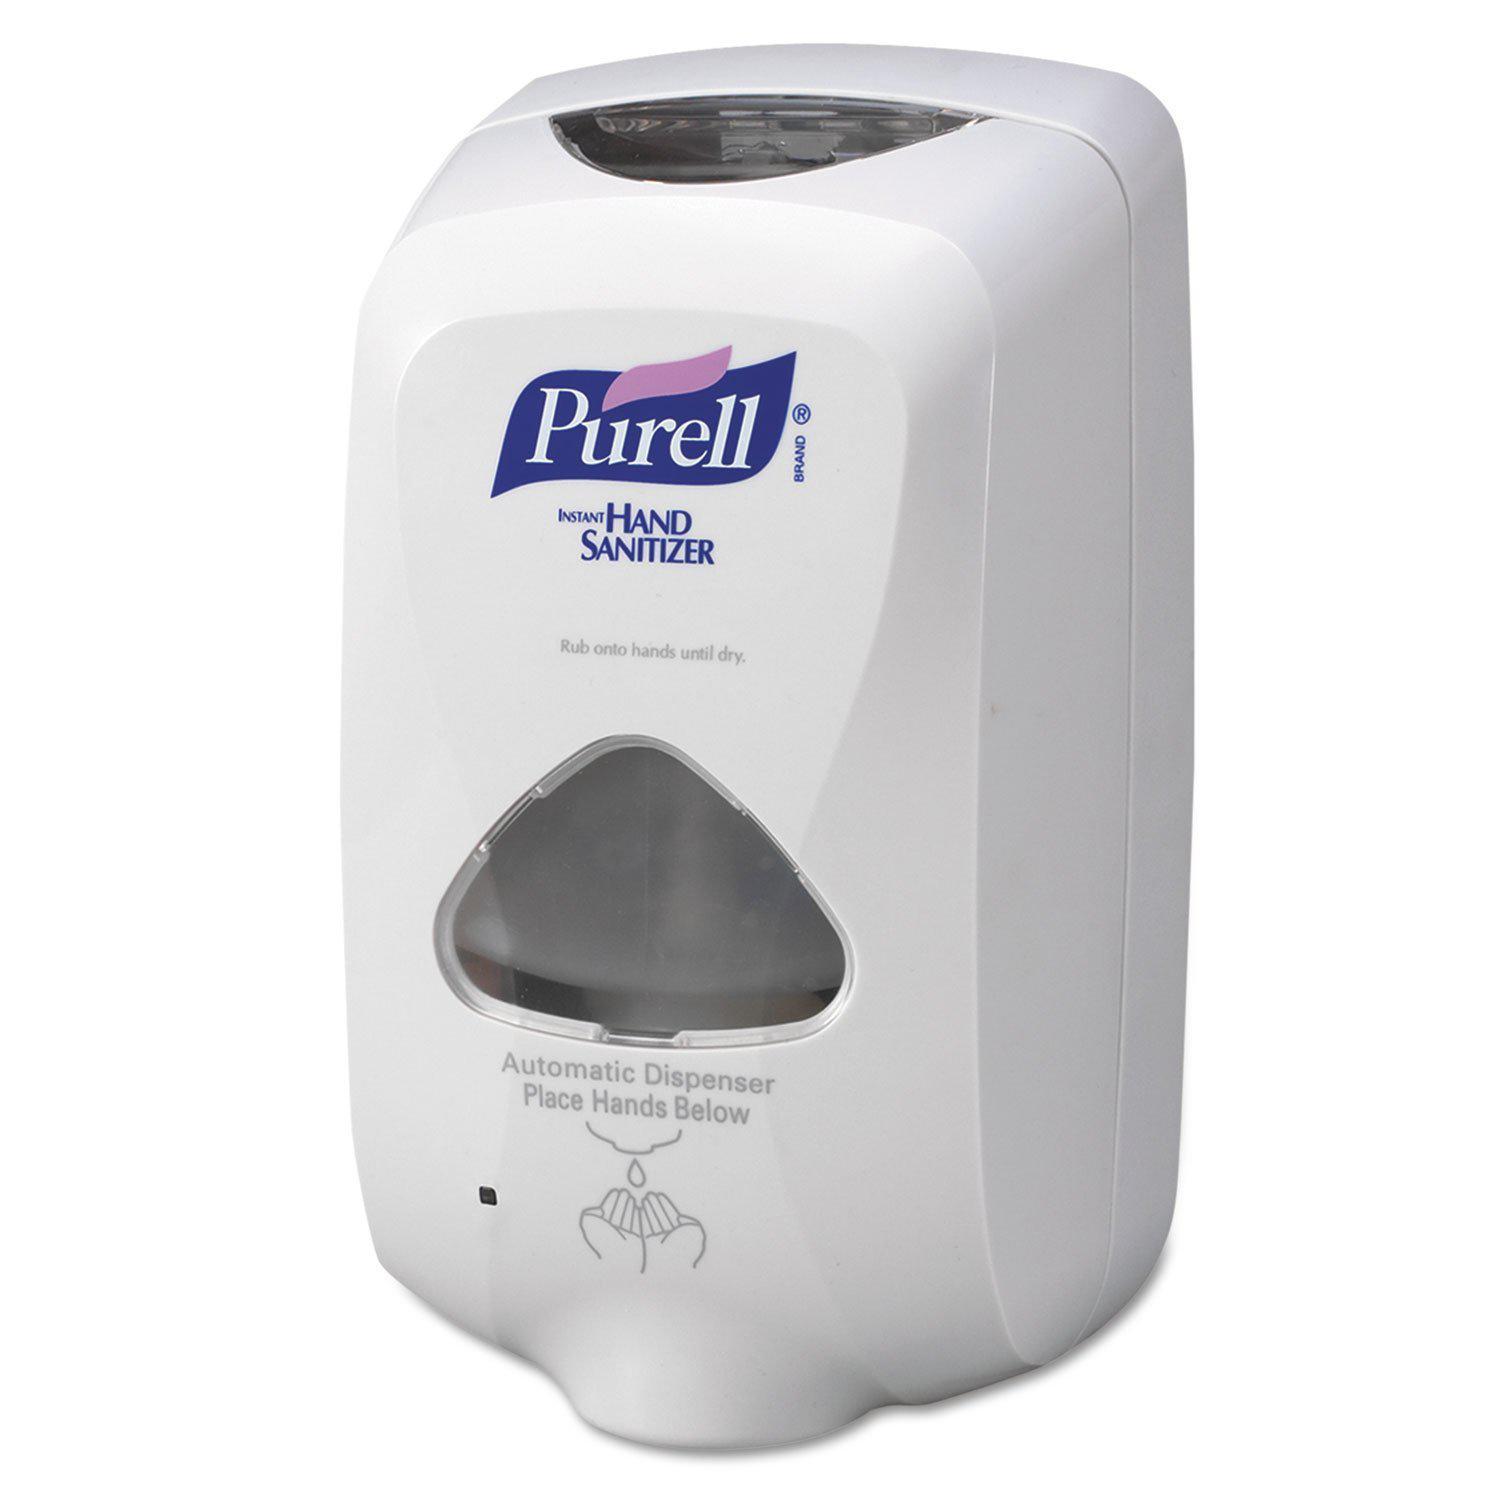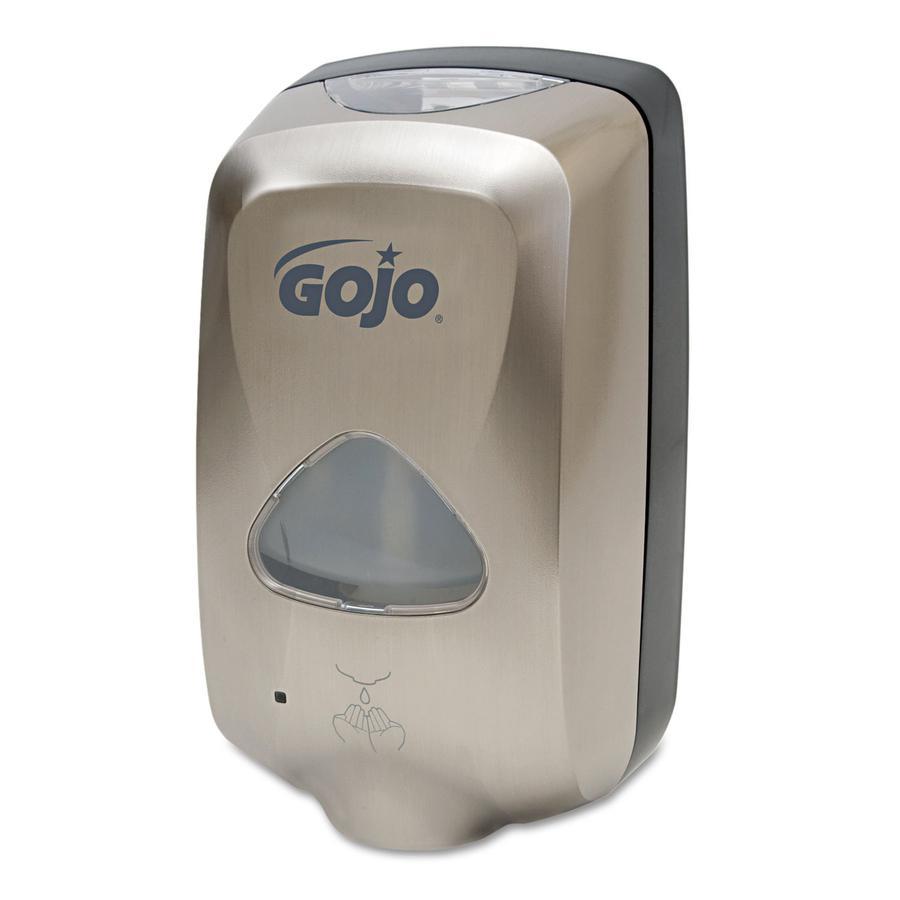The first image is the image on the left, the second image is the image on the right. For the images displayed, is the sentence "One of the soap dispensers is significantly darker than the other." factually correct? Answer yes or no. Yes. The first image is the image on the left, the second image is the image on the right. For the images shown, is this caption "There is exactly one white dispenser." true? Answer yes or no. Yes. 